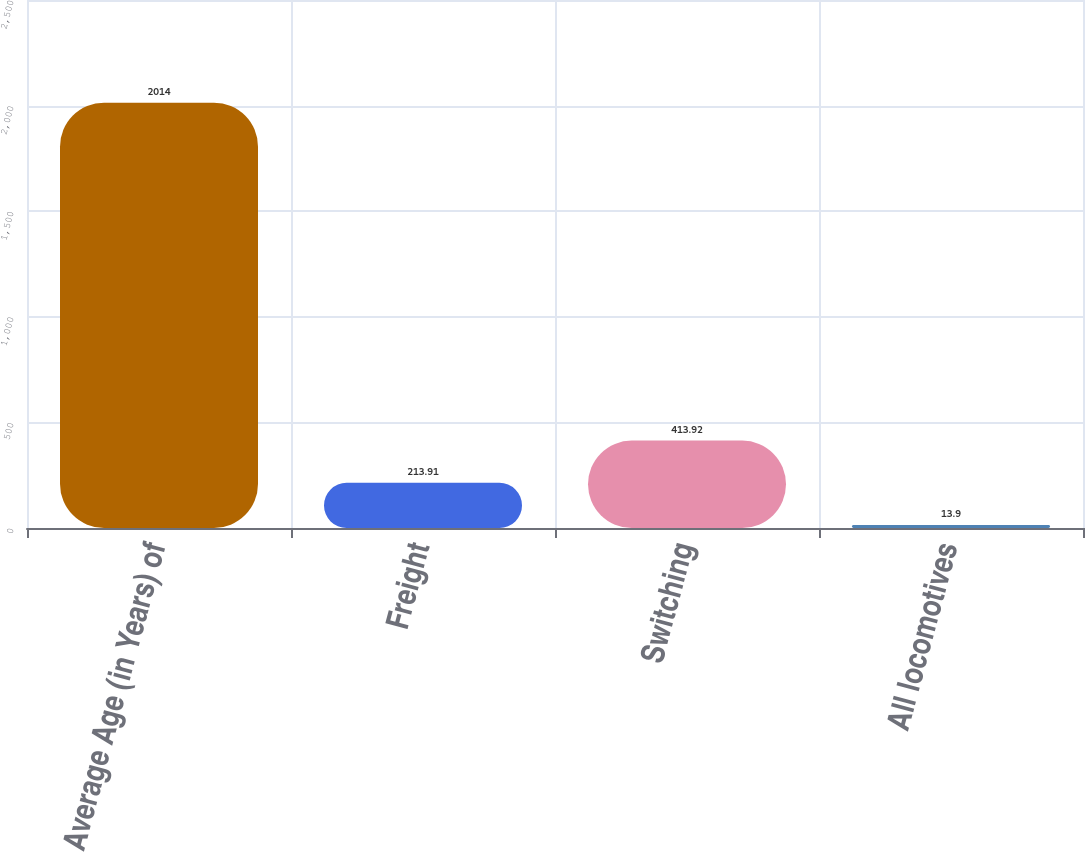Convert chart to OTSL. <chart><loc_0><loc_0><loc_500><loc_500><bar_chart><fcel>Average Age (in Years) of<fcel>Freight<fcel>Switching<fcel>All locomotives<nl><fcel>2014<fcel>213.91<fcel>413.92<fcel>13.9<nl></chart> 